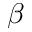<formula> <loc_0><loc_0><loc_500><loc_500>\beta</formula> 